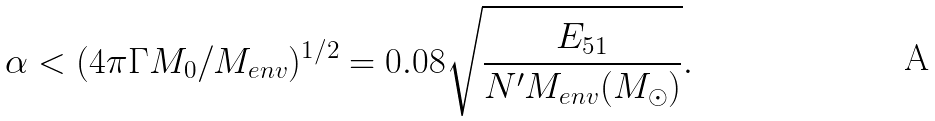<formula> <loc_0><loc_0><loc_500><loc_500>\alpha < ( 4 \pi \Gamma M _ { 0 } / M _ { e n v } ) ^ { 1 / 2 } = 0 . 0 8 \sqrt { \frac { E _ { 5 1 } } { N ^ { \prime } M _ { e n v } ( M _ { \odot } ) } } .</formula> 